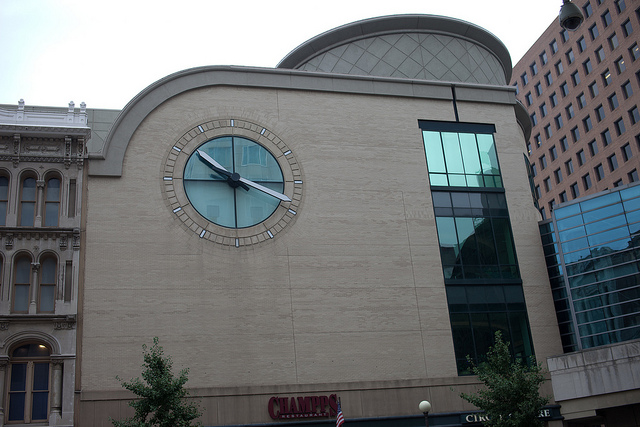Please identify all text content in this image. CHAMPPS 